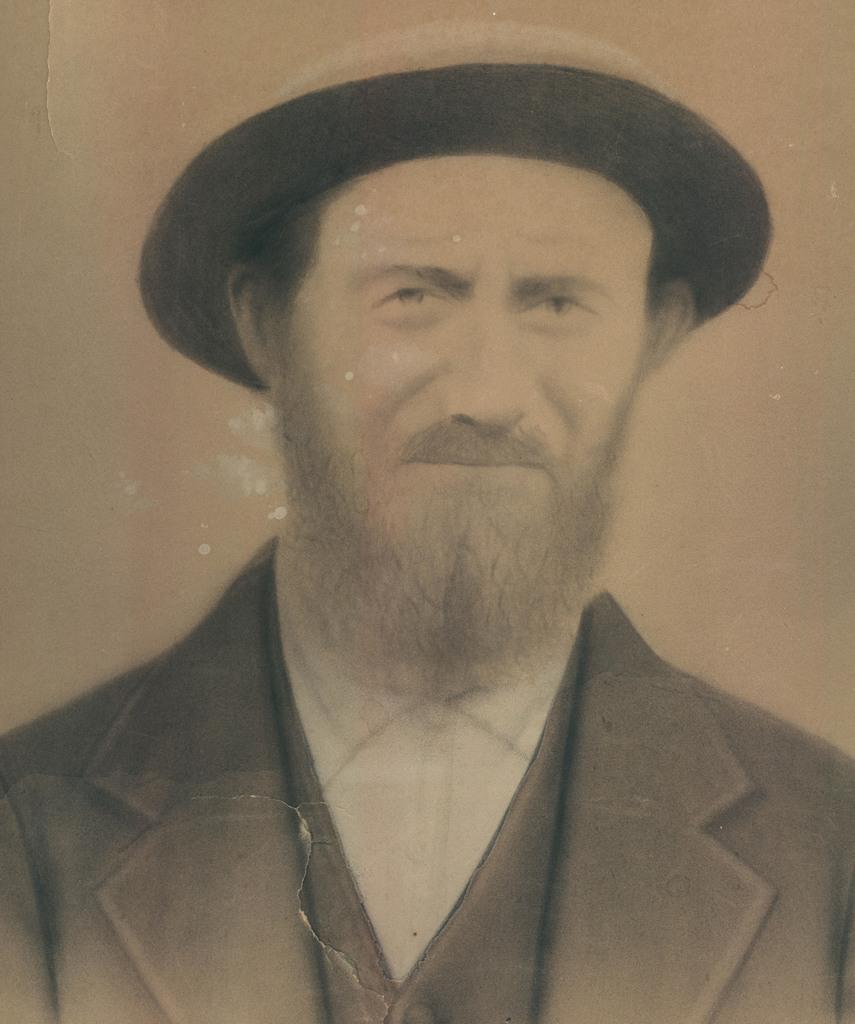What is the main subject of the image? There is a person in the image. What color is the person's shirt? The person is wearing a white shirt. What type of outerwear is the person wearing? The person is wearing a black blazer. What headwear is the person wearing? The person is wearing a hat. What color is the background of the image? The background of the image is brown in color. How many zippers can be seen on the person's apparel in the image? There are no zippers visible on the person's apparel in the image. Are there any bikes present in the image? There are no bikes present in the image. 